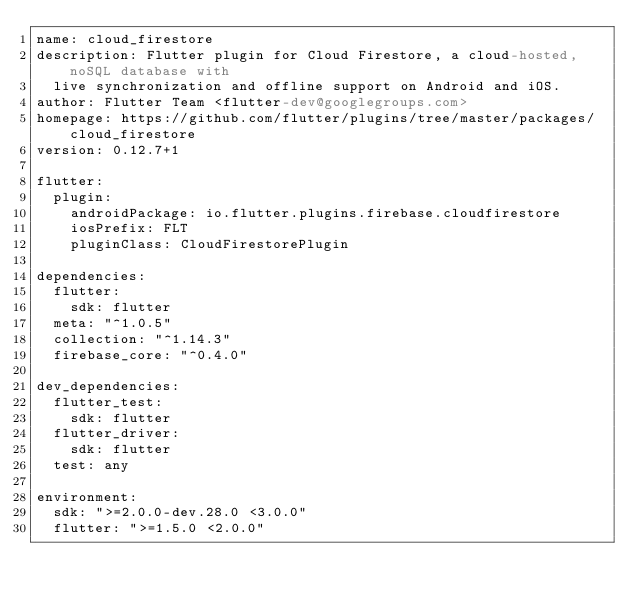Convert code to text. <code><loc_0><loc_0><loc_500><loc_500><_YAML_>name: cloud_firestore
description: Flutter plugin for Cloud Firestore, a cloud-hosted, noSQL database with
  live synchronization and offline support on Android and iOS.
author: Flutter Team <flutter-dev@googlegroups.com>
homepage: https://github.com/flutter/plugins/tree/master/packages/cloud_firestore
version: 0.12.7+1

flutter:
  plugin:
    androidPackage: io.flutter.plugins.firebase.cloudfirestore
    iosPrefix: FLT
    pluginClass: CloudFirestorePlugin

dependencies:
  flutter:
    sdk: flutter
  meta: "^1.0.5"
  collection: "^1.14.3"
  firebase_core: "^0.4.0"

dev_dependencies:
  flutter_test:
    sdk: flutter
  flutter_driver:
    sdk: flutter
  test: any

environment:
  sdk: ">=2.0.0-dev.28.0 <3.0.0"
  flutter: ">=1.5.0 <2.0.0"
</code> 